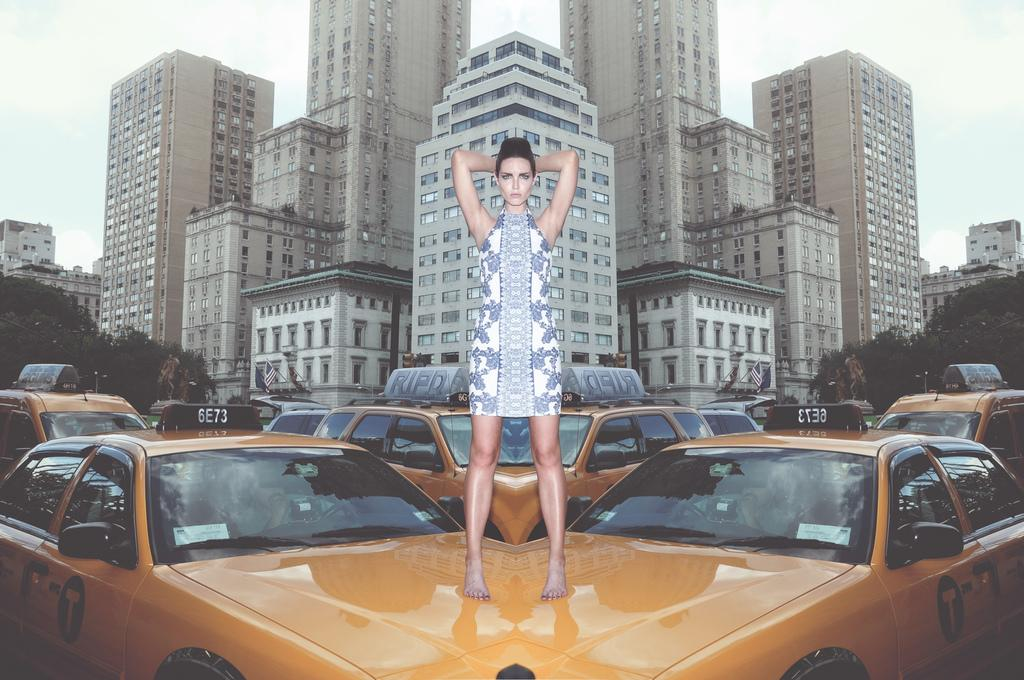<image>
Create a compact narrative representing the image presented. A model stands on top of Taxi 6E73. 